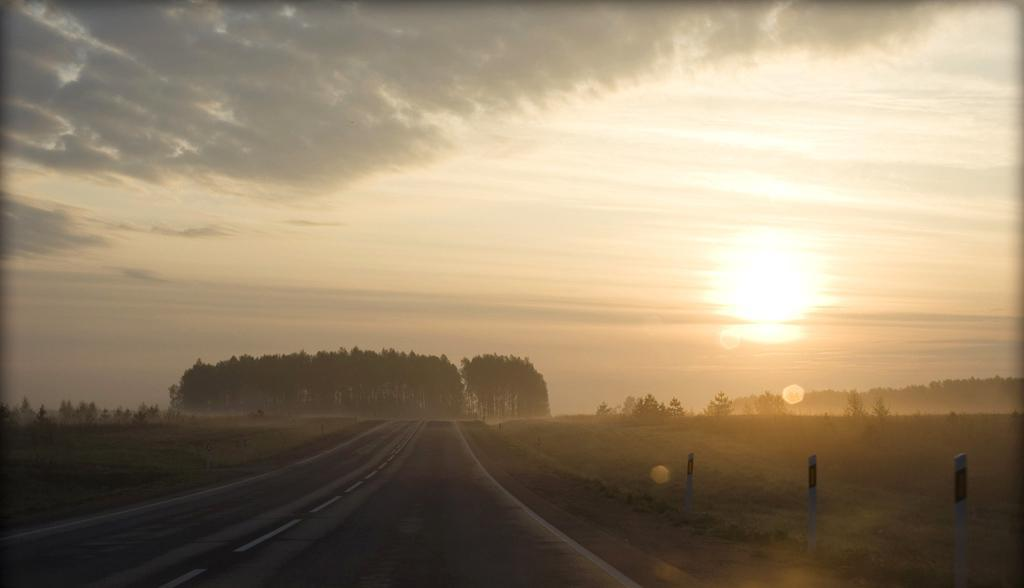What is the main feature of the image? There is a road in the image. What can be seen on the ground on either side of the road? There is green grass on the ground to the left and right of the road. What is visible at the top of the image? The sky is visible at the top of the image. What can be observed in the sky? There is sun in the sky and clouds in the sky. What type of prose is being recited by the clouds in the image? There is no indication in the image that the clouds are reciting any prose. How does the sand in the image contribute to the landscape? There is no sand present in the image; it features a road, green grass, and a sky with sun and clouds. 